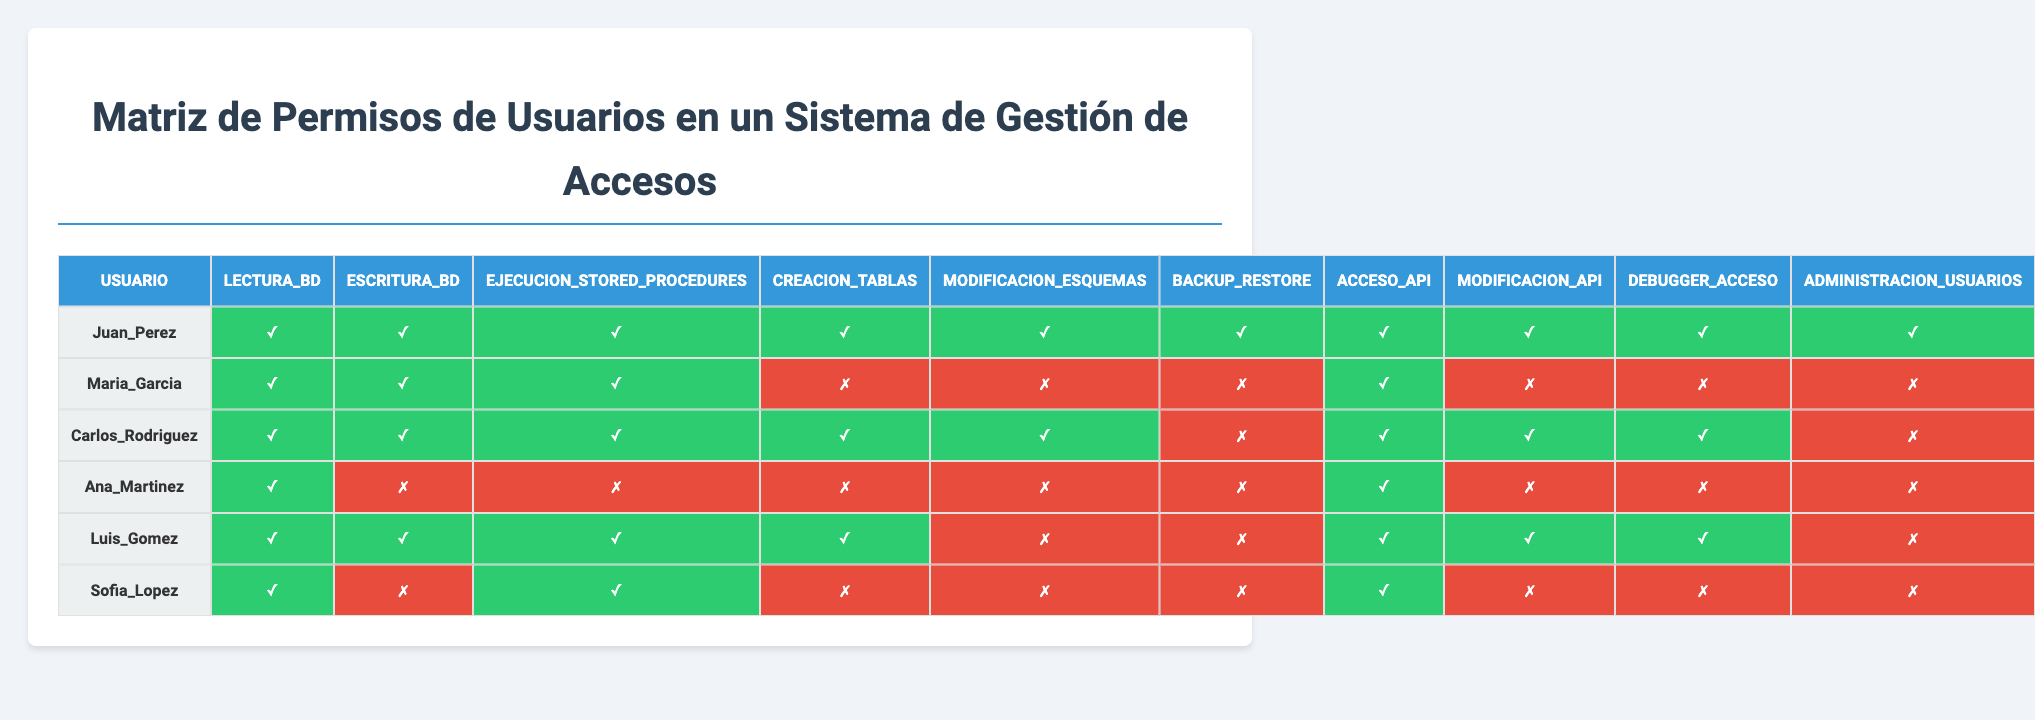¿Cuántos permisos tiene Juan Pérez? Juan Pérez tiene acceso a todos los permisos listados en la tabla, que son diez en total.
Answer: 10 ¿Cuál es el permiso que Ana Martínez no tiene? Al observar la fila de Ana Martínez, se puede ver que no tiene el permiso de Escritura_BD, Ejecucion_Stored_Procedures, Creacion_Tablas, Modificacion_Esquemas, y Administracion_Usuarios.
Answer: Escritura_BD, Ejecucion_Stored_Procedures, Creacion_Tablas, Modificacion_Esquemas, Administracion_Usuarios ¿Luis Gómez tiene permiso de Backup_Restore? La fila correspondiente a Luis Gómez muestra un permiso denegado para Backup_Restore, indicado por un "✗".
Answer: No ¿Quién tiene acceso a la función de Modificación de API? Al observar la columna de Modificación_API, Carlos Rodríguez, Juan Pérez y Luis Gómez tienen permiso, ya que su correspondiente valor es "1".
Answer: Carlos Rodríguez, Juan Pérez, Luis Gómez ¿Cuántos usuarios tienen permiso para ejecutar procedimientos almacenados? Al contar los valores "1" en la columna de Ejecucion_Stored_Procedures, se determina que cinco usuarios tienen acceso a esta función.
Answer: 5 ¿Sofía López tiene acceso a la API? La tabla muestra que el valor en la columna de Acceso_API para Sofía López es "1", lo que indica que tiene acceso.
Answer: Sí ¿Cuál es la diferencia en permisos de acceso API entre Carlos Rodríguez y Ana Martínez? Carlos Rodríguez tiene un permiso de "1" (acceso) mientras que Ana Martínez tiene "0" (sin acceso), lo que implica que la diferencia es de 1 permiso a favor de Carlos.
Answer: 1 ¿Qué porcentaje de permisos tiene María García en comparación con Juan Pérez? María García tiene 7 permisos (de 10) y Juan Pérez tiene 10 permisos. Por lo tanto, el porcentaje de permisos de María García respecto a Juan Pérez es (7/10)*100 = 70%.
Answer: 70% ¿Hay algún usuario que no tiene acceso a la función de Administración de Usuarios? Al revisar la columna de Administración_Usuarios, se observa que solamente Sofía López y Ana Martínez tienen un "0", lo que significa que no tienen acceso a esta función.
Answer: Sí Si sumamos todos los permisos otorgados a Luis Gómez, ¿cuál sería el total? Al contar los "1" en la fila de Luis Gómez, se observa que tiene 7 permisos otorgados.
Answer: 7 